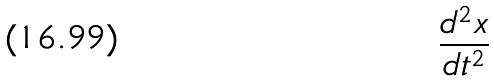Convert formula to latex. <formula><loc_0><loc_0><loc_500><loc_500>\frac { d ^ { 2 } x } { d t ^ { 2 } }</formula> 